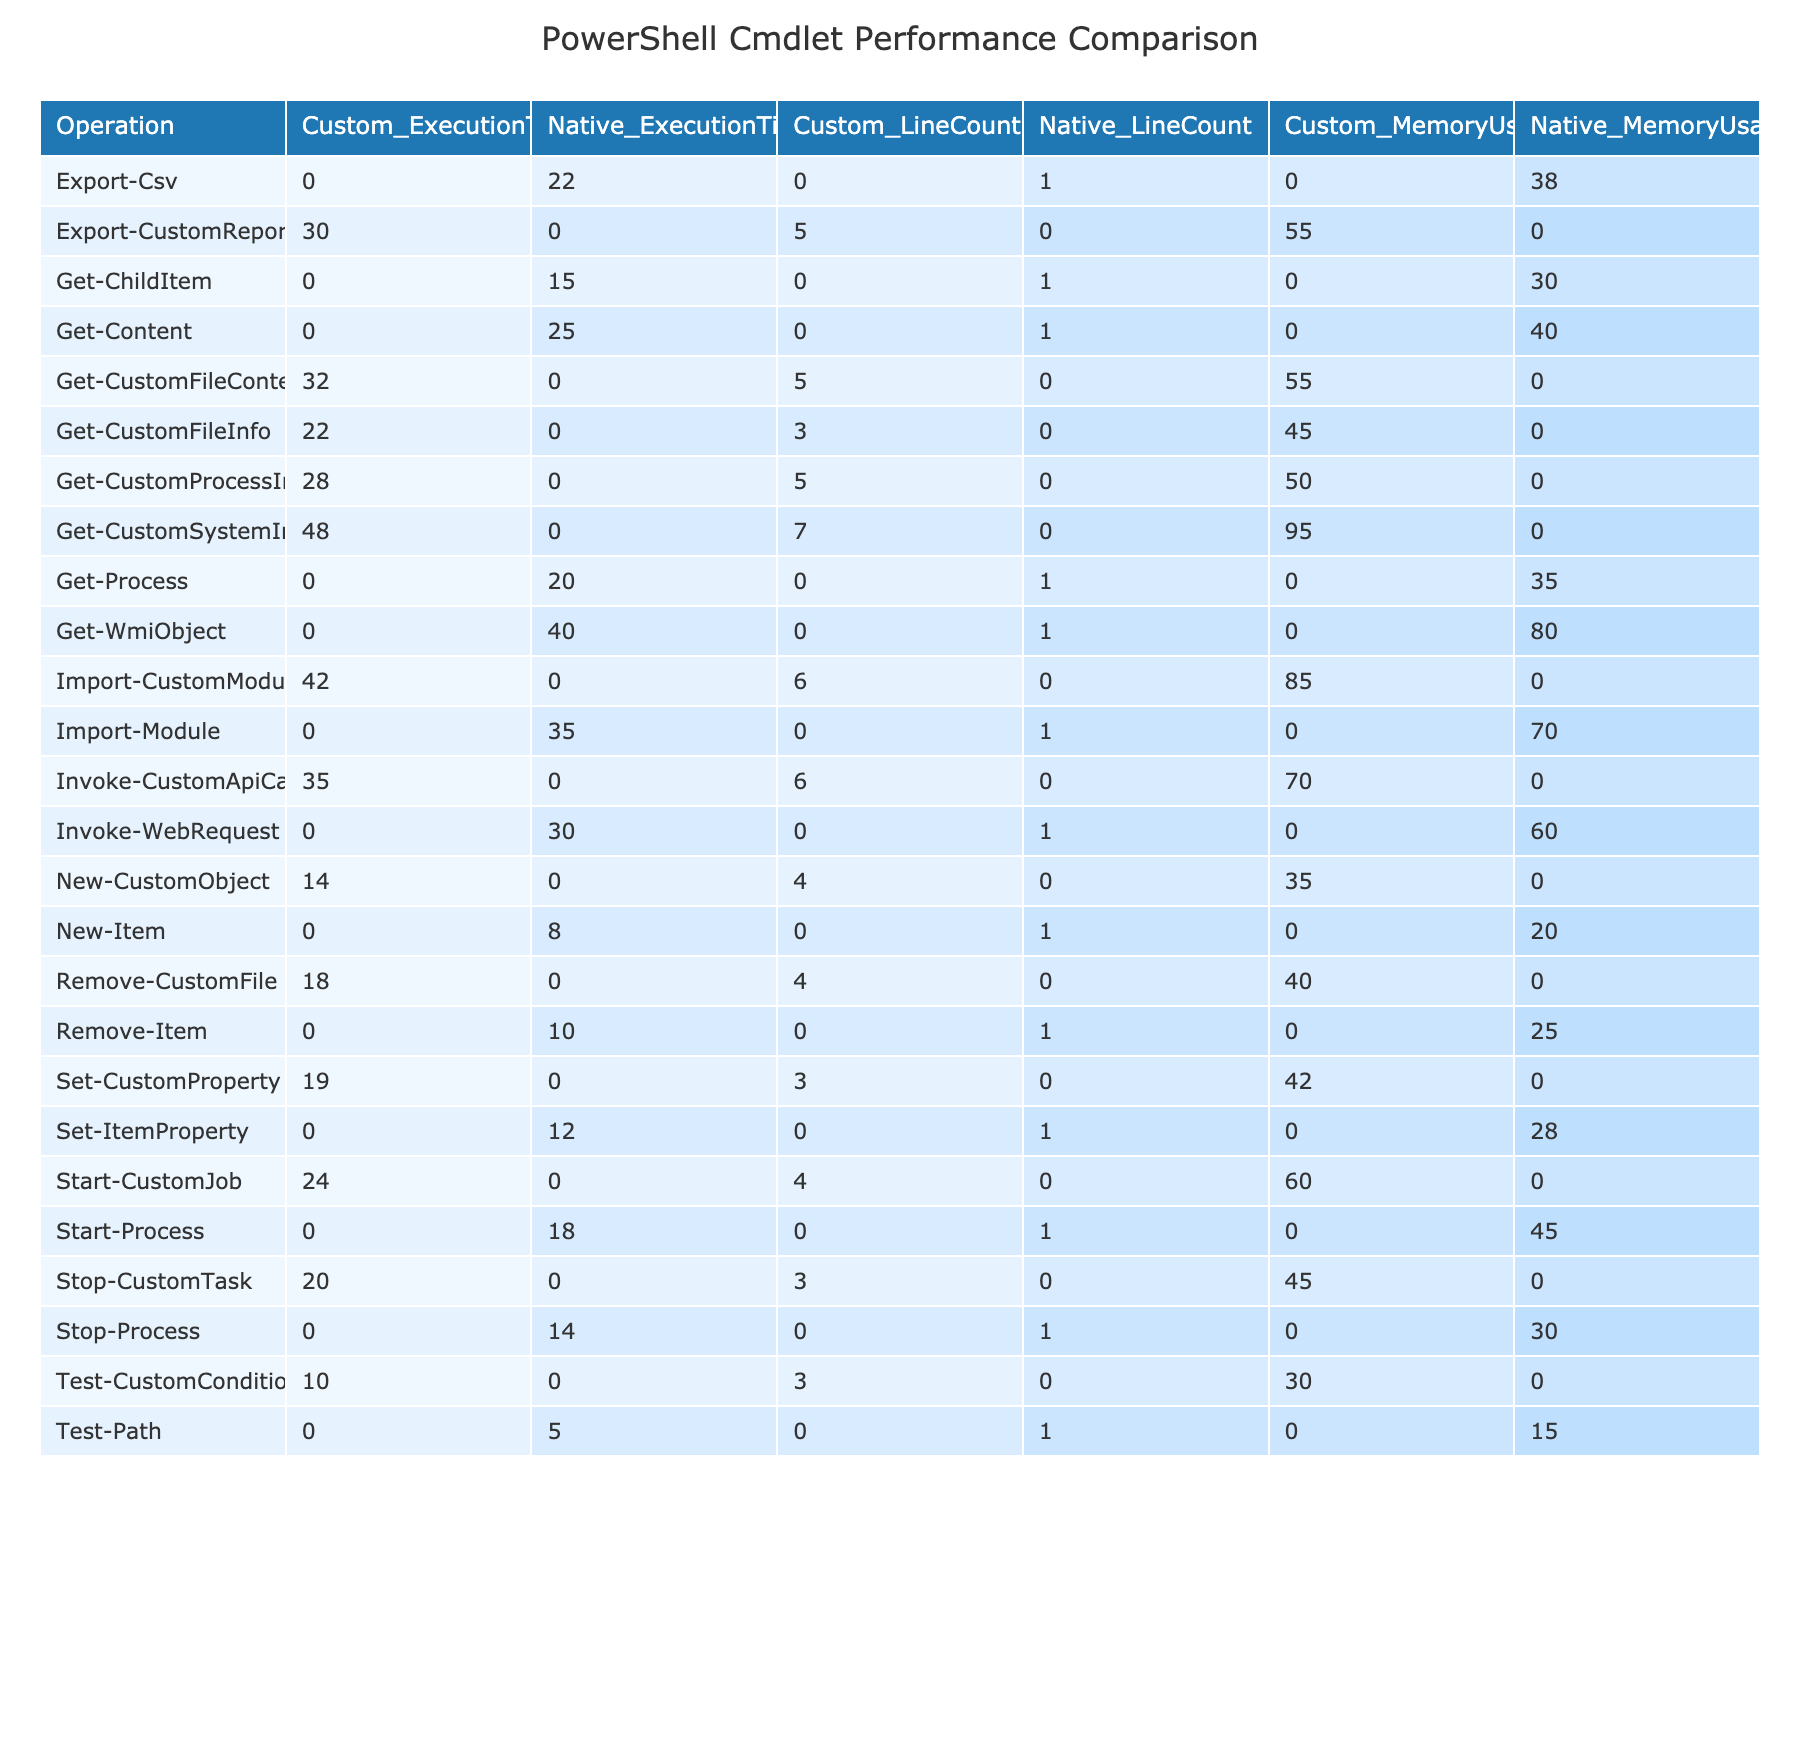What is the execution time for the Get-CustomFileInfo cmdlet? The execution time for the Get-CustomFileInfo cmdlet is directly listed in the table under the ExecutionTime column for the Custom category, which shows 22.
Answer: 22 Which cmdlet has the highest memory usage? By looking at the MemoryUsage column for both cmdlet types, the highest value is found in the Get-CustomSystemInfo cmdlet, which has a usage of 95.
Answer: 95 What is the difference in execution time between Get-Process and Get-CustomProcessInfo? The execution time for Get-Process is 20, and for Get-CustomProcessInfo, it is 28. The difference is calculated as 28 - 20 = 8.
Answer: 8 Is the memory usage for New-CustomObject greater than the execution time for Invoke-WebRequest? New-CustomObject has a memory usage of 35 and Invoke-WebRequest has an execution time of 30. Since 35 is greater than 30, the answer is yes.
Answer: Yes What is the average execution time for custom cmdlets? First, we sum the execution times for all Custom cmdlets: 22 + 18 + 28 + 19 + 35 + 14 + 10 + 32 + 24 + 20 + 30 + 42 + 48 =  320. There are 13 Custom cmdlets, so the average is 320 / 13 = approximately 24.62.
Answer: 24.62 How many custom cmdlets have a complexity rating of High? In the Complexity column, we count the entries listed as High for the Custom type. They are: Get-CustomProcessInfo, Invoke-CustomApiCall, Get-CustomFileContent, Start-CustomJob, Import-CustomModule, and Get-CustomSystemInfo, totaling 6 custom cmdlets.
Answer: 6 What is the average memory usage for native commands? Summing the memory usage for native commands gives 30 + 25 + 35 + 28 + 60 + 20 + 15 + 40 + 45 + 30 + 38 + 70 + 80 = 508. There are 13 native commands, so the average memory usage is 508 / 13 = approximately 39.08.
Answer: 39.08 Compare the line count for Remove-CustomFile and Remove-Item; which has a higher line count and by how much? The line count for Remove-CustomFile is 4 and for Remove-Item, it is 1. The difference is 4 - 1 = 3, so Remove-CustomFile has a higher line count by 3 lines.
Answer: 3 Is there a cmdlet that has the same execution time for both native and custom types? By inspecting the ExecutionTime values in the table, none of the cmdlets have identical execution times in both categories; they are all different.
Answer: No 